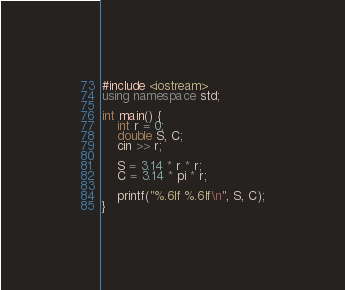Convert code to text. <code><loc_0><loc_0><loc_500><loc_500><_C++_>#include <iostream>
using namespace std;

int main() {
    int r = 0;
    double S, C;
    cin >> r;

    S = 3.14 * r * r;
    C = 3.14 * pi * r;

    printf("%.6lf %.6lf\n", S, C);
}</code> 